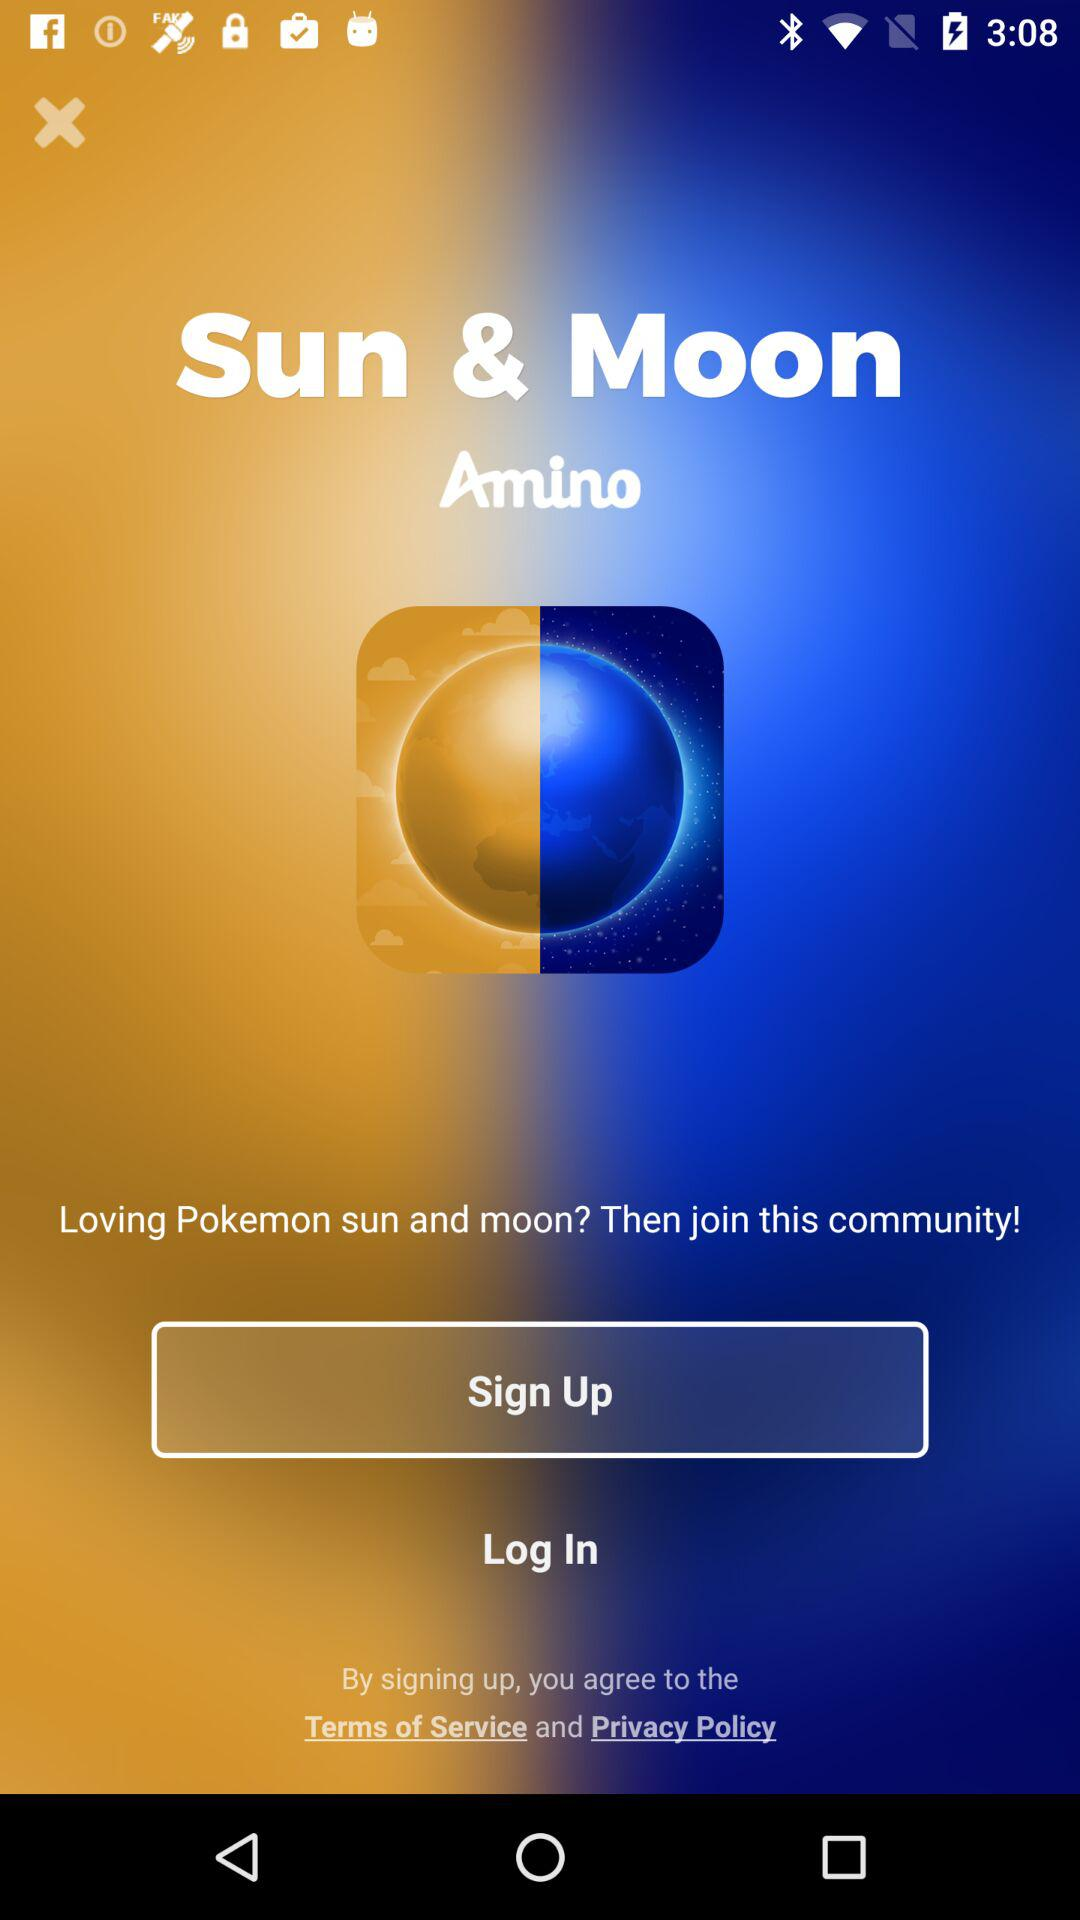What is the application name? The application name is "Amino". 